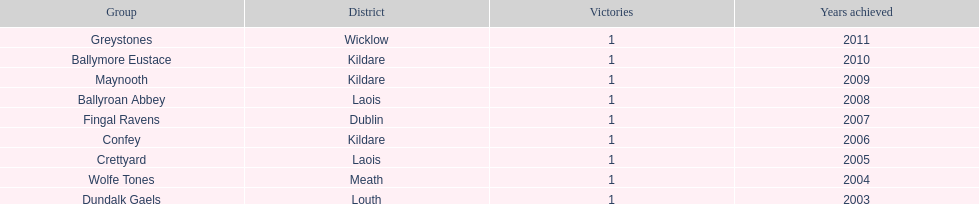Which county had the most number of wins? Kildare. 